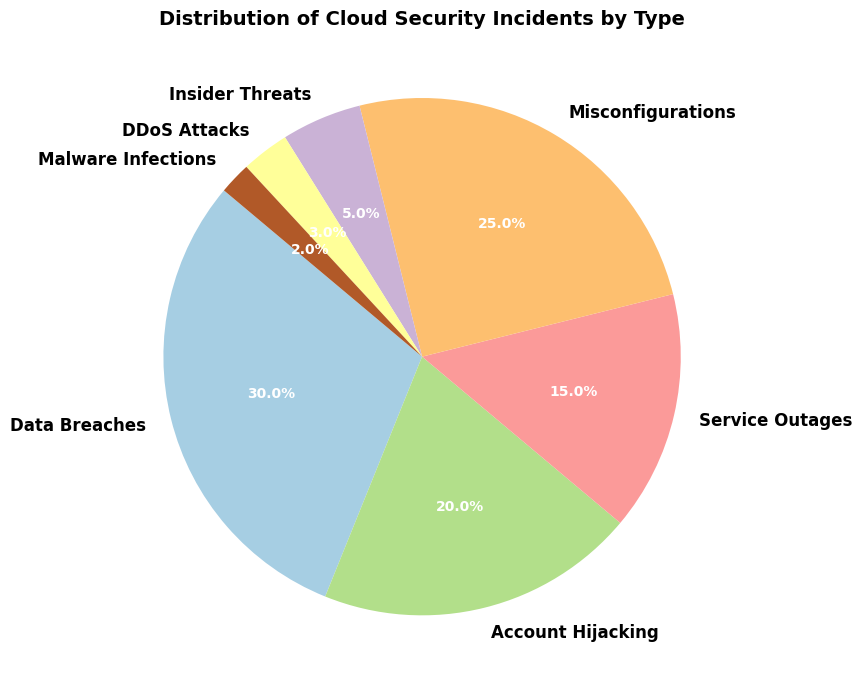What type of cloud security incident is the most common? The type of incident with the highest percentage will be the most common. In the pie chart, Data Breaches have the largest segment.
Answer: Data Breaches What percentage of cloud security incidents are due to Misconfigurations? Look at the segment labeled "Misconfigurations" in the pie chart, and read the percentage value indicated.
Answer: 25% Which type of incident is less frequent: DDoS Attacks or Malware Infections? Compare the percentage values of DDoS Attacks and Malware Infections from the pie chart. DDoS Attacks have 3%, and Malware Infections have 2%.
Answer: Malware Infections What is the combined percentage of Service Outages and Insider Threats? Add the percentage values for Service Outages and Insider Threats from the pie chart (15% + 5%).
Answer: 20% Which two types of incidents together account for 50% of the total incidents? Look for the combination of two types whose percentages add up to 50%. Data Breaches and Account Hijacking together total 50% (30% + 20%).
Answer: Data Breaches and Account Hijacking Are Misconfigurations more common than Account Hijacking? Compare the segment sizes for Misconfigurations and Account Hijacking. Misconfigurations are 25%, and Account Hijacking is 20%.
Answer: Yes What visual attribute indicates the proportion of each cloud security incident type in the pie chart? The size (angle) of each segment represents the proportion of each incident type in the pie chart distribution. Larger segments correspond to higher proportions.
Answer: Size of segments How does the percentage of Data Breaches compare to the combined percentage of Insider Threats, DDoS Attacks, and Malware Infections? Compare 30% for Data Breaches to the sum of Insider Threats (5%), DDoS Attacks (3%), and Malware Infections (2%), which equals 10%. 30% is significantly larger.
Answer: Larger Which type of incident has a percentage closest to the average percentage of all incidents? Calculate the average of all incident percentages: (30% + 20% + 15% + 25% + 5% + 3% + 2%) / 7 = 14.29%. Service Outages are closest with 15%.
Answer: Service Outages What is the difference in percentage between Account Hijacking and Service Outages? Subtract the percentage of Service Outages (15%) from Account Hijacking (20%). 20% - 15% = 5%.
Answer: 5% 